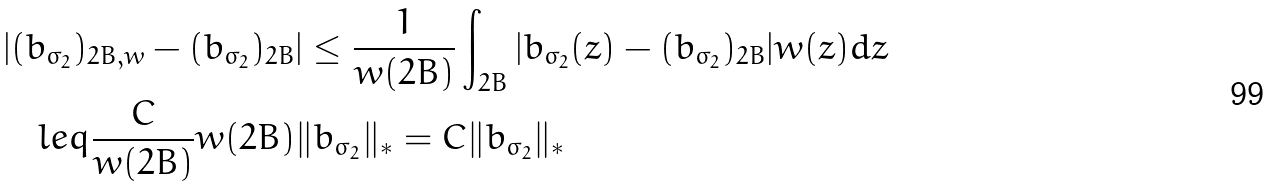<formula> <loc_0><loc_0><loc_500><loc_500>& | ( b _ { \sigma _ { 2 } } ) _ { 2 B , w } - ( b _ { \sigma _ { 2 } } ) _ { 2 B } | \leq \frac { 1 } { w ( 2 B ) } \int _ { 2 B } | b _ { \sigma _ { 2 } } ( z ) - ( b _ { \sigma _ { 2 } } ) _ { 2 B } | w ( z ) d z \\ & \quad l e q \frac { C } { w ( 2 B ) } w ( 2 B ) \| b _ { \sigma _ { 2 } } \| _ { * } = C \| b _ { \sigma _ { 2 } } \| _ { * }</formula> 